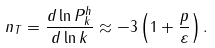<formula> <loc_0><loc_0><loc_500><loc_500>n _ { T } = { \frac { d \ln P _ { k } ^ { h } } { d \ln k } } \approx - 3 \left ( 1 + \frac { p } { \varepsilon } \right ) .</formula> 